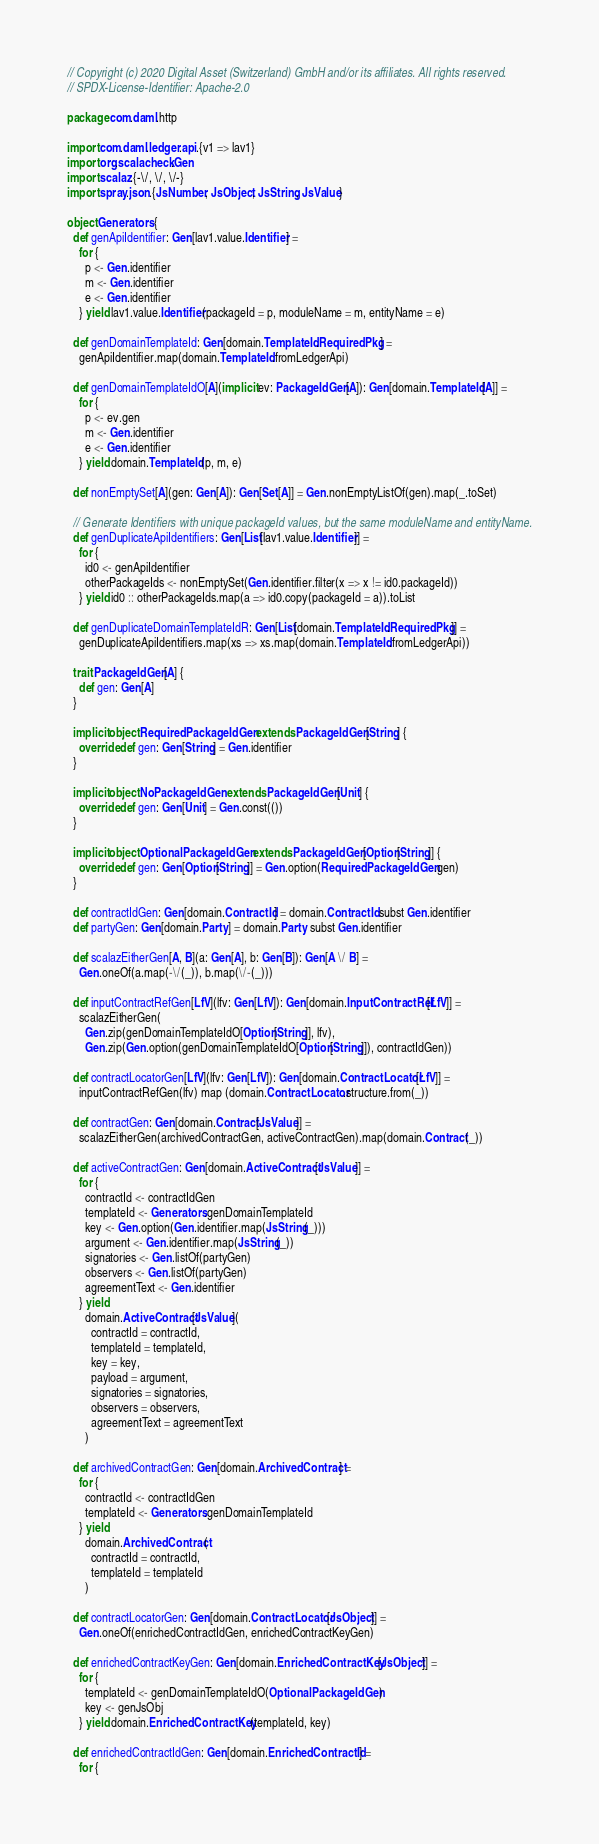<code> <loc_0><loc_0><loc_500><loc_500><_Scala_>// Copyright (c) 2020 Digital Asset (Switzerland) GmbH and/or its affiliates. All rights reserved.
// SPDX-License-Identifier: Apache-2.0

package com.daml.http

import com.daml.ledger.api.{v1 => lav1}
import org.scalacheck.Gen
import scalaz.{-\/, \/, \/-}
import spray.json.{JsNumber, JsObject, JsString, JsValue}

object Generators {
  def genApiIdentifier: Gen[lav1.value.Identifier] =
    for {
      p <- Gen.identifier
      m <- Gen.identifier
      e <- Gen.identifier
    } yield lav1.value.Identifier(packageId = p, moduleName = m, entityName = e)

  def genDomainTemplateId: Gen[domain.TemplateId.RequiredPkg] =
    genApiIdentifier.map(domain.TemplateId.fromLedgerApi)

  def genDomainTemplateIdO[A](implicit ev: PackageIdGen[A]): Gen[domain.TemplateId[A]] =
    for {
      p <- ev.gen
      m <- Gen.identifier
      e <- Gen.identifier
    } yield domain.TemplateId(p, m, e)

  def nonEmptySet[A](gen: Gen[A]): Gen[Set[A]] = Gen.nonEmptyListOf(gen).map(_.toSet)

  // Generate Identifiers with unique packageId values, but the same moduleName and entityName.
  def genDuplicateApiIdentifiers: Gen[List[lav1.value.Identifier]] =
    for {
      id0 <- genApiIdentifier
      otherPackageIds <- nonEmptySet(Gen.identifier.filter(x => x != id0.packageId))
    } yield id0 :: otherPackageIds.map(a => id0.copy(packageId = a)).toList

  def genDuplicateDomainTemplateIdR: Gen[List[domain.TemplateId.RequiredPkg]] =
    genDuplicateApiIdentifiers.map(xs => xs.map(domain.TemplateId.fromLedgerApi))

  trait PackageIdGen[A] {
    def gen: Gen[A]
  }

  implicit object RequiredPackageIdGen extends PackageIdGen[String] {
    override def gen: Gen[String] = Gen.identifier
  }

  implicit object NoPackageIdGen extends PackageIdGen[Unit] {
    override def gen: Gen[Unit] = Gen.const(())
  }

  implicit object OptionalPackageIdGen extends PackageIdGen[Option[String]] {
    override def gen: Gen[Option[String]] = Gen.option(RequiredPackageIdGen.gen)
  }

  def contractIdGen: Gen[domain.ContractId] = domain.ContractId subst Gen.identifier
  def partyGen: Gen[domain.Party] = domain.Party subst Gen.identifier

  def scalazEitherGen[A, B](a: Gen[A], b: Gen[B]): Gen[A \/ B] =
    Gen.oneOf(a.map(-\/(_)), b.map(\/-(_)))

  def inputContractRefGen[LfV](lfv: Gen[LfV]): Gen[domain.InputContractRef[LfV]] =
    scalazEitherGen(
      Gen.zip(genDomainTemplateIdO[Option[String]], lfv),
      Gen.zip(Gen.option(genDomainTemplateIdO[Option[String]]), contractIdGen))

  def contractLocatorGen[LfV](lfv: Gen[LfV]): Gen[domain.ContractLocator[LfV]] =
    inputContractRefGen(lfv) map (domain.ContractLocator.structure.from(_))

  def contractGen: Gen[domain.Contract[JsValue]] =
    scalazEitherGen(archivedContractGen, activeContractGen).map(domain.Contract(_))

  def activeContractGen: Gen[domain.ActiveContract[JsValue]] =
    for {
      contractId <- contractIdGen
      templateId <- Generators.genDomainTemplateId
      key <- Gen.option(Gen.identifier.map(JsString(_)))
      argument <- Gen.identifier.map(JsString(_))
      signatories <- Gen.listOf(partyGen)
      observers <- Gen.listOf(partyGen)
      agreementText <- Gen.identifier
    } yield
      domain.ActiveContract[JsValue](
        contractId = contractId,
        templateId = templateId,
        key = key,
        payload = argument,
        signatories = signatories,
        observers = observers,
        agreementText = agreementText
      )

  def archivedContractGen: Gen[domain.ArchivedContract] =
    for {
      contractId <- contractIdGen
      templateId <- Generators.genDomainTemplateId
    } yield
      domain.ArchivedContract(
        contractId = contractId,
        templateId = templateId
      )

  def contractLocatorGen: Gen[domain.ContractLocator[JsObject]] =
    Gen.oneOf(enrichedContractIdGen, enrichedContractKeyGen)

  def enrichedContractKeyGen: Gen[domain.EnrichedContractKey[JsObject]] =
    for {
      templateId <- genDomainTemplateIdO(OptionalPackageIdGen)
      key <- genJsObj
    } yield domain.EnrichedContractKey(templateId, key)

  def enrichedContractIdGen: Gen[domain.EnrichedContractId] =
    for {</code> 